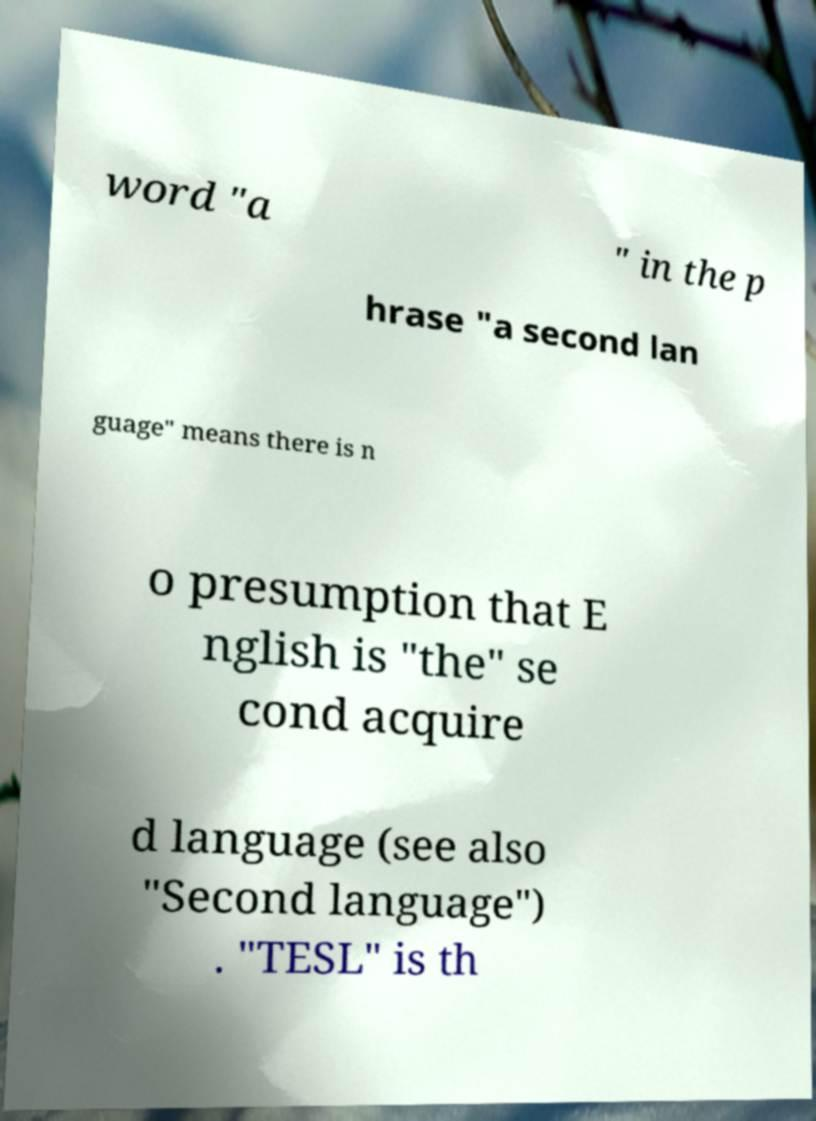For documentation purposes, I need the text within this image transcribed. Could you provide that? word "a " in the p hrase "a second lan guage" means there is n o presumption that E nglish is "the" se cond acquire d language (see also "Second language") . "TESL" is th 